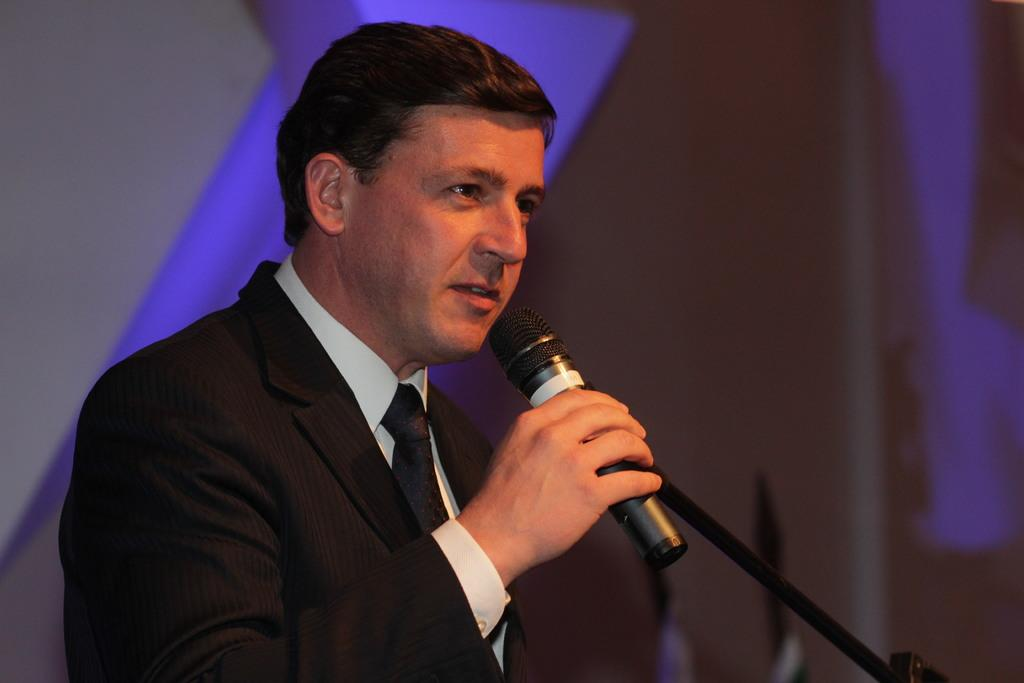Who is present in the image? There is a man in the image. What is the man wearing? The man is wearing a black suit. What is the man holding in his hand? The man is holding a mic in his hand. What type of ornament is hanging from the man's neck in the image? There is no ornament hanging from the man's neck in the image; he is only wearing a black suit and holding a mic. 